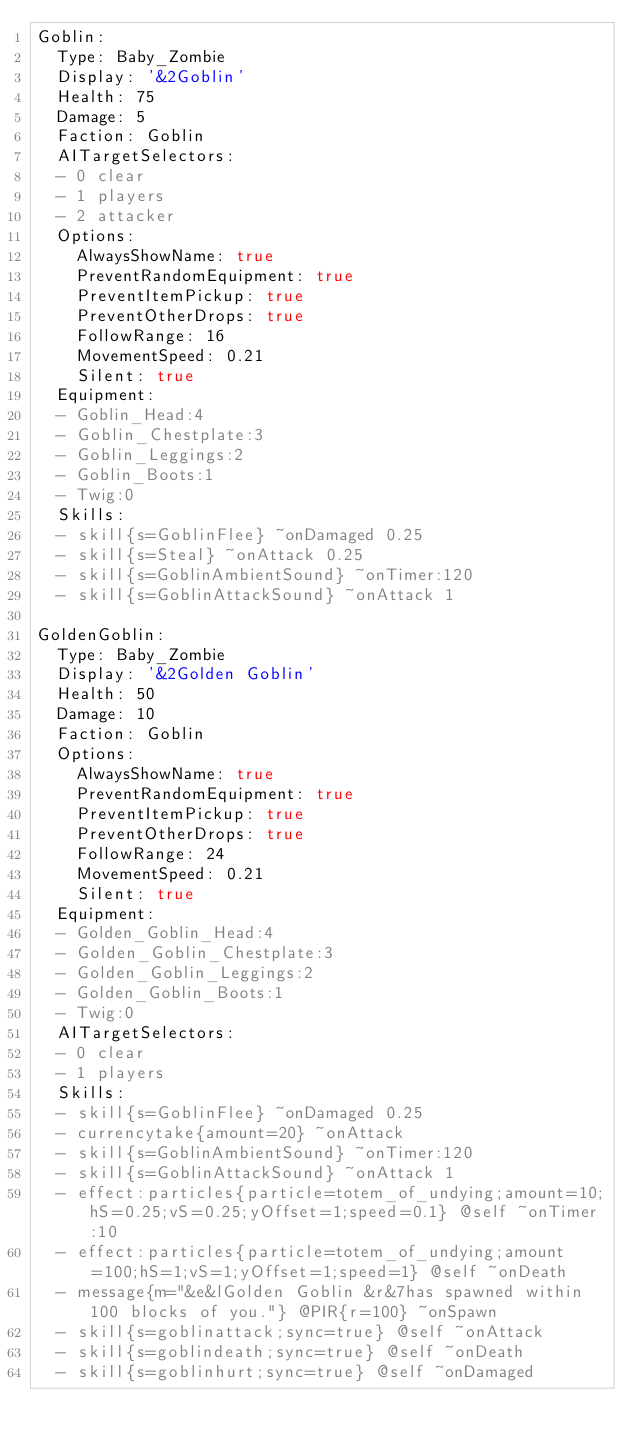Convert code to text. <code><loc_0><loc_0><loc_500><loc_500><_YAML_>Goblin:
  Type: Baby_Zombie
  Display: '&2Goblin'
  Health: 75
  Damage: 5
  Faction: Goblin
  AITargetSelectors:
  - 0 clear
  - 1 players
  - 2 attacker
  Options:
    AlwaysShowName: true
    PreventRandomEquipment: true
    PreventItemPickup: true
    PreventOtherDrops: true
    FollowRange: 16
    MovementSpeed: 0.21
    Silent: true
  Equipment:
  - Goblin_Head:4
  - Goblin_Chestplate:3
  - Goblin_Leggings:2
  - Goblin_Boots:1
  - Twig:0
  Skills:
  - skill{s=GoblinFlee} ~onDamaged 0.25
  - skill{s=Steal} ~onAttack 0.25
  - skill{s=GoblinAmbientSound} ~onTimer:120
  - skill{s=GoblinAttackSound} ~onAttack 1

GoldenGoblin:
  Type: Baby_Zombie
  Display: '&2Golden Goblin'
  Health: 50
  Damage: 10
  Faction: Goblin
  Options:
    AlwaysShowName: true
    PreventRandomEquipment: true
    PreventItemPickup: true
    PreventOtherDrops: true
    FollowRange: 24
    MovementSpeed: 0.21
    Silent: true
  Equipment:
  - Golden_Goblin_Head:4
  - Golden_Goblin_Chestplate:3
  - Golden_Goblin_Leggings:2
  - Golden_Goblin_Boots:1
  - Twig:0
  AITargetSelectors:
  - 0 clear
  - 1 players
  Skills:
  - skill{s=GoblinFlee} ~onDamaged 0.25
  - currencytake{amount=20} ~onAttack
  - skill{s=GoblinAmbientSound} ~onTimer:120
  - skill{s=GoblinAttackSound} ~onAttack 1
  - effect:particles{particle=totem_of_undying;amount=10;hS=0.25;vS=0.25;yOffset=1;speed=0.1} @self ~onTimer:10
  - effect:particles{particle=totem_of_undying;amount=100;hS=1;vS=1;yOffset=1;speed=1} @self ~onDeath
  - message{m="&e&lGolden Goblin &r&7has spawned within 100 blocks of you."} @PIR{r=100} ~onSpawn
  - skill{s=goblinattack;sync=true} @self ~onAttack
  - skill{s=goblindeath;sync=true} @self ~onDeath
  - skill{s=goblinhurt;sync=true} @self ~onDamaged</code> 